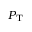Convert formula to latex. <formula><loc_0><loc_0><loc_500><loc_500>P _ { T }</formula> 